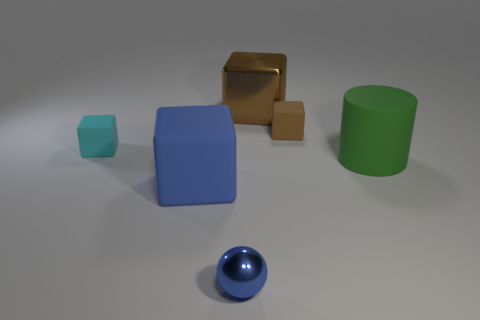Subtract all big blue blocks. How many blocks are left? 3 Add 3 red objects. How many objects exist? 9 Subtract all cyan cubes. How many cubes are left? 3 Subtract all red cylinders. How many brown cubes are left? 2 Subtract all cubes. How many objects are left? 2 Subtract 1 blocks. How many blocks are left? 3 Add 2 matte objects. How many matte objects are left? 6 Add 3 tiny things. How many tiny things exist? 6 Subtract 0 purple spheres. How many objects are left? 6 Subtract all yellow cubes. Subtract all green balls. How many cubes are left? 4 